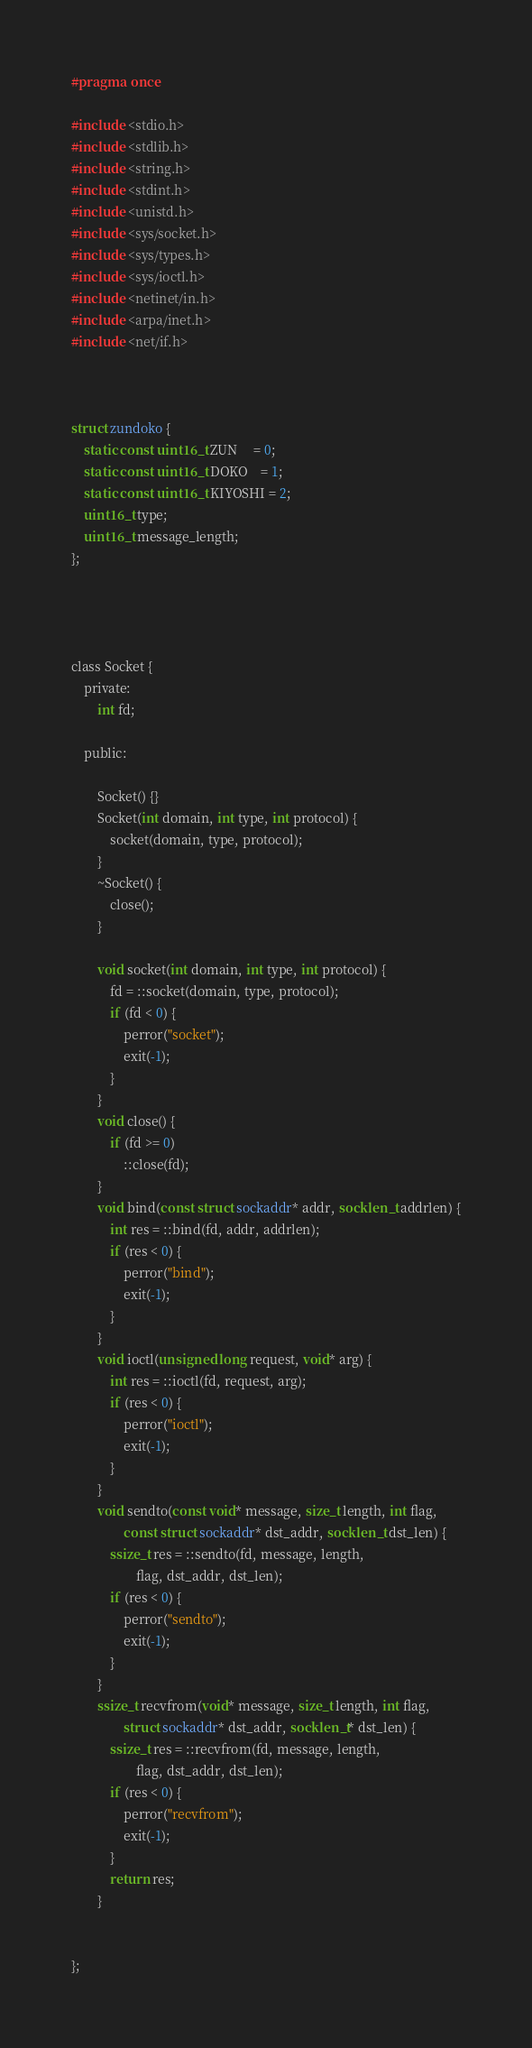<code> <loc_0><loc_0><loc_500><loc_500><_C_>
#pragma once

#include <stdio.h>
#include <stdlib.h>
#include <string.h>
#include <stdint.h>
#include <unistd.h>
#include <sys/socket.h>
#include <sys/types.h>
#include <sys/ioctl.h>
#include <netinet/in.h>
#include <arpa/inet.h>
#include <net/if.h>



struct zundoko {
    static const uint16_t ZUN     = 0;
    static const uint16_t DOKO    = 1;
    static const uint16_t KIYOSHI = 2;
    uint16_t type;
    uint16_t message_length;
};




class Socket {
    private:
        int fd;

    public:
        
        Socket() {}
        Socket(int domain, int type, int protocol) {
            socket(domain, type, protocol);   
        }
        ~Socket() {
            close();
        }

        void socket(int domain, int type, int protocol) {
            fd = ::socket(domain, type, protocol);
            if (fd < 0) {
                perror("socket");
                exit(-1);
            }
        }
        void close() {
            if (fd >= 0) 
                ::close(fd);
        }
        void bind(const struct sockaddr* addr, socklen_t addrlen) {
            int res = ::bind(fd, addr, addrlen);
            if (res < 0) {
                perror("bind");
                exit(-1);
            }
        }
        void ioctl(unsigned long request, void* arg) {
            int res = ::ioctl(fd, request, arg);
            if (res < 0) {
                perror("ioctl");
                exit(-1);
            }
        }
        void sendto(const void* message, size_t length, int flag, 
                const struct sockaddr* dst_addr, socklen_t dst_len) {
            ssize_t res = ::sendto(fd, message, length, 
                    flag, dst_addr, dst_len);
            if (res < 0) {
                perror("sendto");
                exit(-1);
            }
        }
        ssize_t recvfrom(void* message, size_t length, int flag, 
                struct sockaddr* dst_addr, socklen_t* dst_len) {
            ssize_t res = ::recvfrom(fd, message, length, 
                    flag, dst_addr, dst_len);
            if (res < 0) {
                perror("recvfrom");
                exit(-1);
            }
            return res;
        }

    
};
</code> 